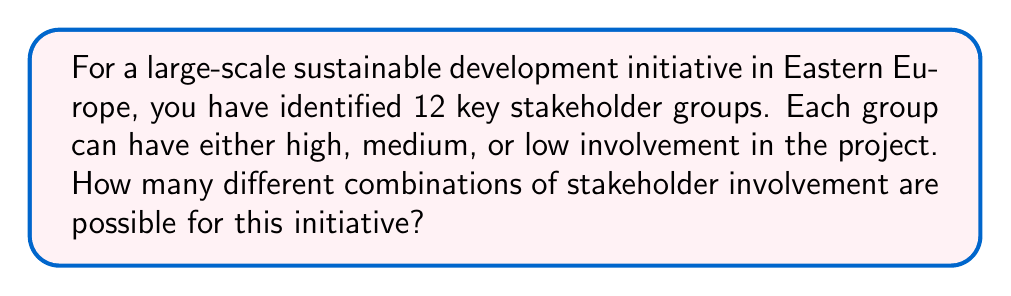Help me with this question. Let's approach this step-by-step:

1) We have 12 stakeholder groups, and each group has 3 possible levels of involvement (high, medium, or low).

2) This scenario can be modeled as a combination problem where we are making 12 independent choices, each with 3 options.

3) In combinatorics, when we have a series of independent choices, we multiply the number of options for each choice.

4) In this case, we have 3 options for each of the 12 stakeholder groups.

5) Therefore, the total number of combinations is:

   $$3 \times 3 \times 3 \times ... \text{ (12 times) } ... \times 3 = 3^{12}$$

6) Let's calculate this:
   
   $$3^{12} = 531,441$$

Thus, there are 531,441 different possible combinations of stakeholder involvement for this sustainable development initiative.
Answer: $3^{12} = 531,441$ 